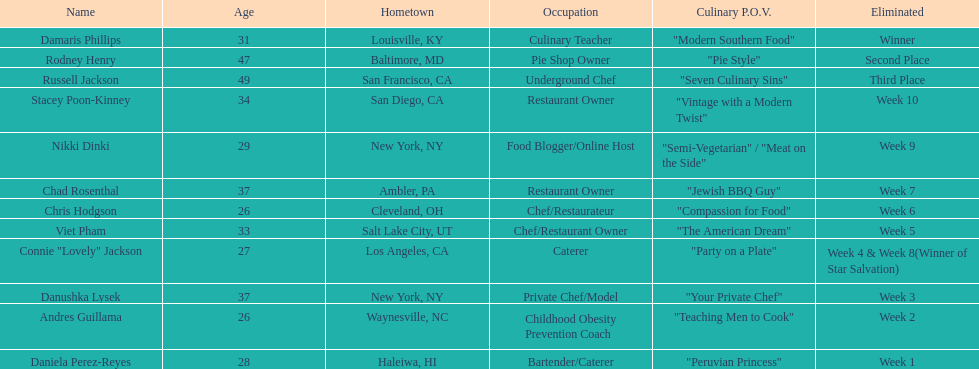Help me parse the entirety of this table. {'header': ['Name', 'Age', 'Hometown', 'Occupation', 'Culinary P.O.V.', 'Eliminated'], 'rows': [['Damaris Phillips', '31', 'Louisville, KY', 'Culinary Teacher', '"Modern Southern Food"', 'Winner'], ['Rodney Henry', '47', 'Baltimore, MD', 'Pie Shop Owner', '"Pie Style"', 'Second Place'], ['Russell Jackson', '49', 'San Francisco, CA', 'Underground Chef', '"Seven Culinary Sins"', 'Third Place'], ['Stacey Poon-Kinney', '34', 'San Diego, CA', 'Restaurant Owner', '"Vintage with a Modern Twist"', 'Week 10'], ['Nikki Dinki', '29', 'New York, NY', 'Food Blogger/Online Host', '"Semi-Vegetarian" / "Meat on the Side"', 'Week 9'], ['Chad Rosenthal', '37', 'Ambler, PA', 'Restaurant Owner', '"Jewish BBQ Guy"', 'Week 7'], ['Chris Hodgson', '26', 'Cleveland, OH', 'Chef/Restaurateur', '"Compassion for Food"', 'Week 6'], ['Viet Pham', '33', 'Salt Lake City, UT', 'Chef/Restaurant Owner', '"The American Dream"', 'Week 5'], ['Connie "Lovely" Jackson', '27', 'Los Angeles, CA', 'Caterer', '"Party on a Plate"', 'Week 4 & Week 8(Winner of Star Salvation)'], ['Danushka Lysek', '37', 'New York, NY', 'Private Chef/Model', '"Your Private Chef"', 'Week 3'], ['Andres Guillama', '26', 'Waynesville, NC', 'Childhood Obesity Prevention Coach', '"Teaching Men to Cook"', 'Week 2'], ['Daniela Perez-Reyes', '28', 'Haleiwa, HI', 'Bartender/Caterer', '"Peruvian Princess"', 'Week 1']]} For which contestant was their culinary approach elaborated more than "vintage with a modern twist"? Nikki Dinki. 